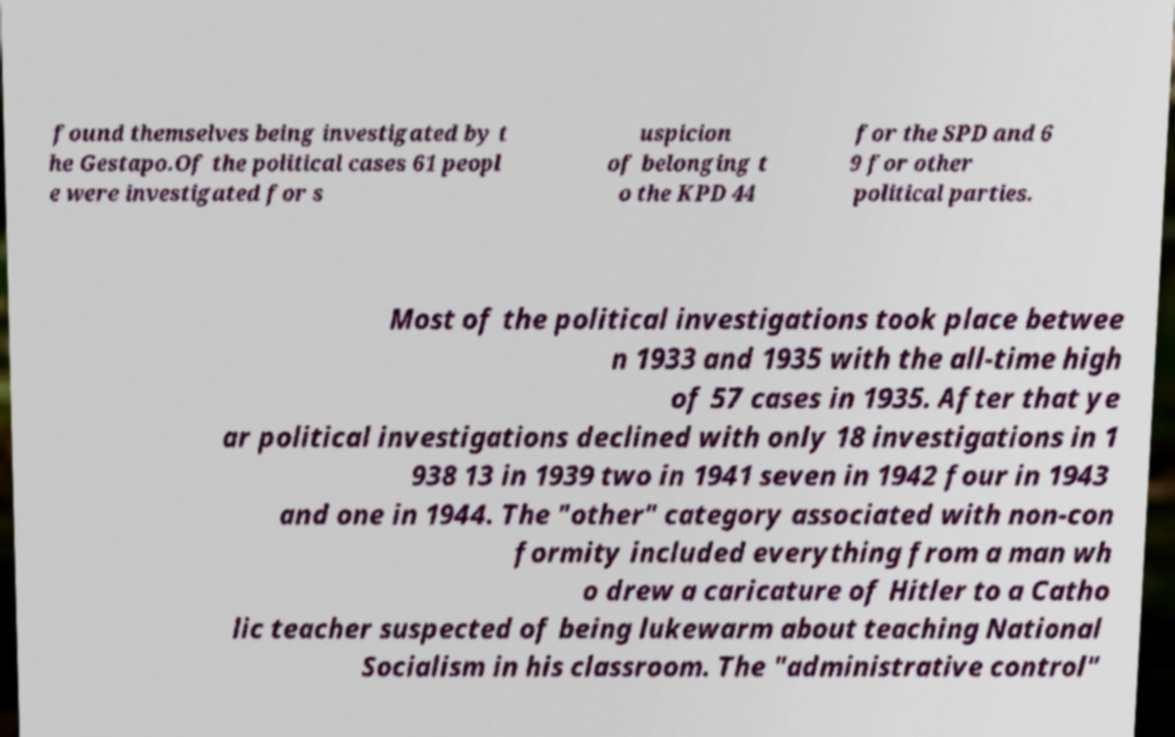What messages or text are displayed in this image? I need them in a readable, typed format. found themselves being investigated by t he Gestapo.Of the political cases 61 peopl e were investigated for s uspicion of belonging t o the KPD 44 for the SPD and 6 9 for other political parties. Most of the political investigations took place betwee n 1933 and 1935 with the all-time high of 57 cases in 1935. After that ye ar political investigations declined with only 18 investigations in 1 938 13 in 1939 two in 1941 seven in 1942 four in 1943 and one in 1944. The "other" category associated with non-con formity included everything from a man wh o drew a caricature of Hitler to a Catho lic teacher suspected of being lukewarm about teaching National Socialism in his classroom. The "administrative control" 